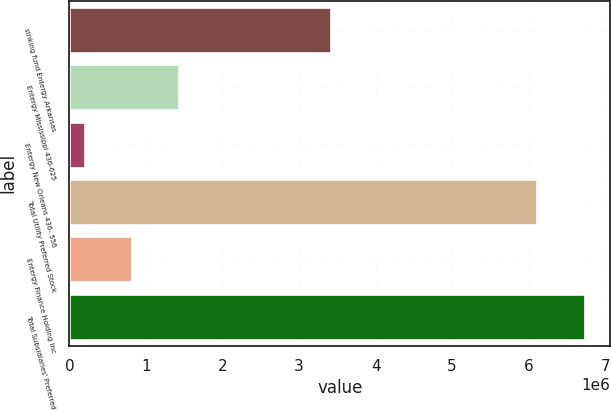Convert chart to OTSL. <chart><loc_0><loc_0><loc_500><loc_500><bar_chart><fcel>sinking fund Entergy Arkansas<fcel>Entergy Mississippi 436-625<fcel>Entergy New Orleans 436- 556<fcel>Total Utility Preferred Stock<fcel>Entergy Finance Holding Inc<fcel>Total Subsidiaries' Preferred<nl><fcel>3.4135e+06<fcel>1.43126e+06<fcel>197798<fcel>6.1151e+06<fcel>814529<fcel>6.73184e+06<nl></chart> 